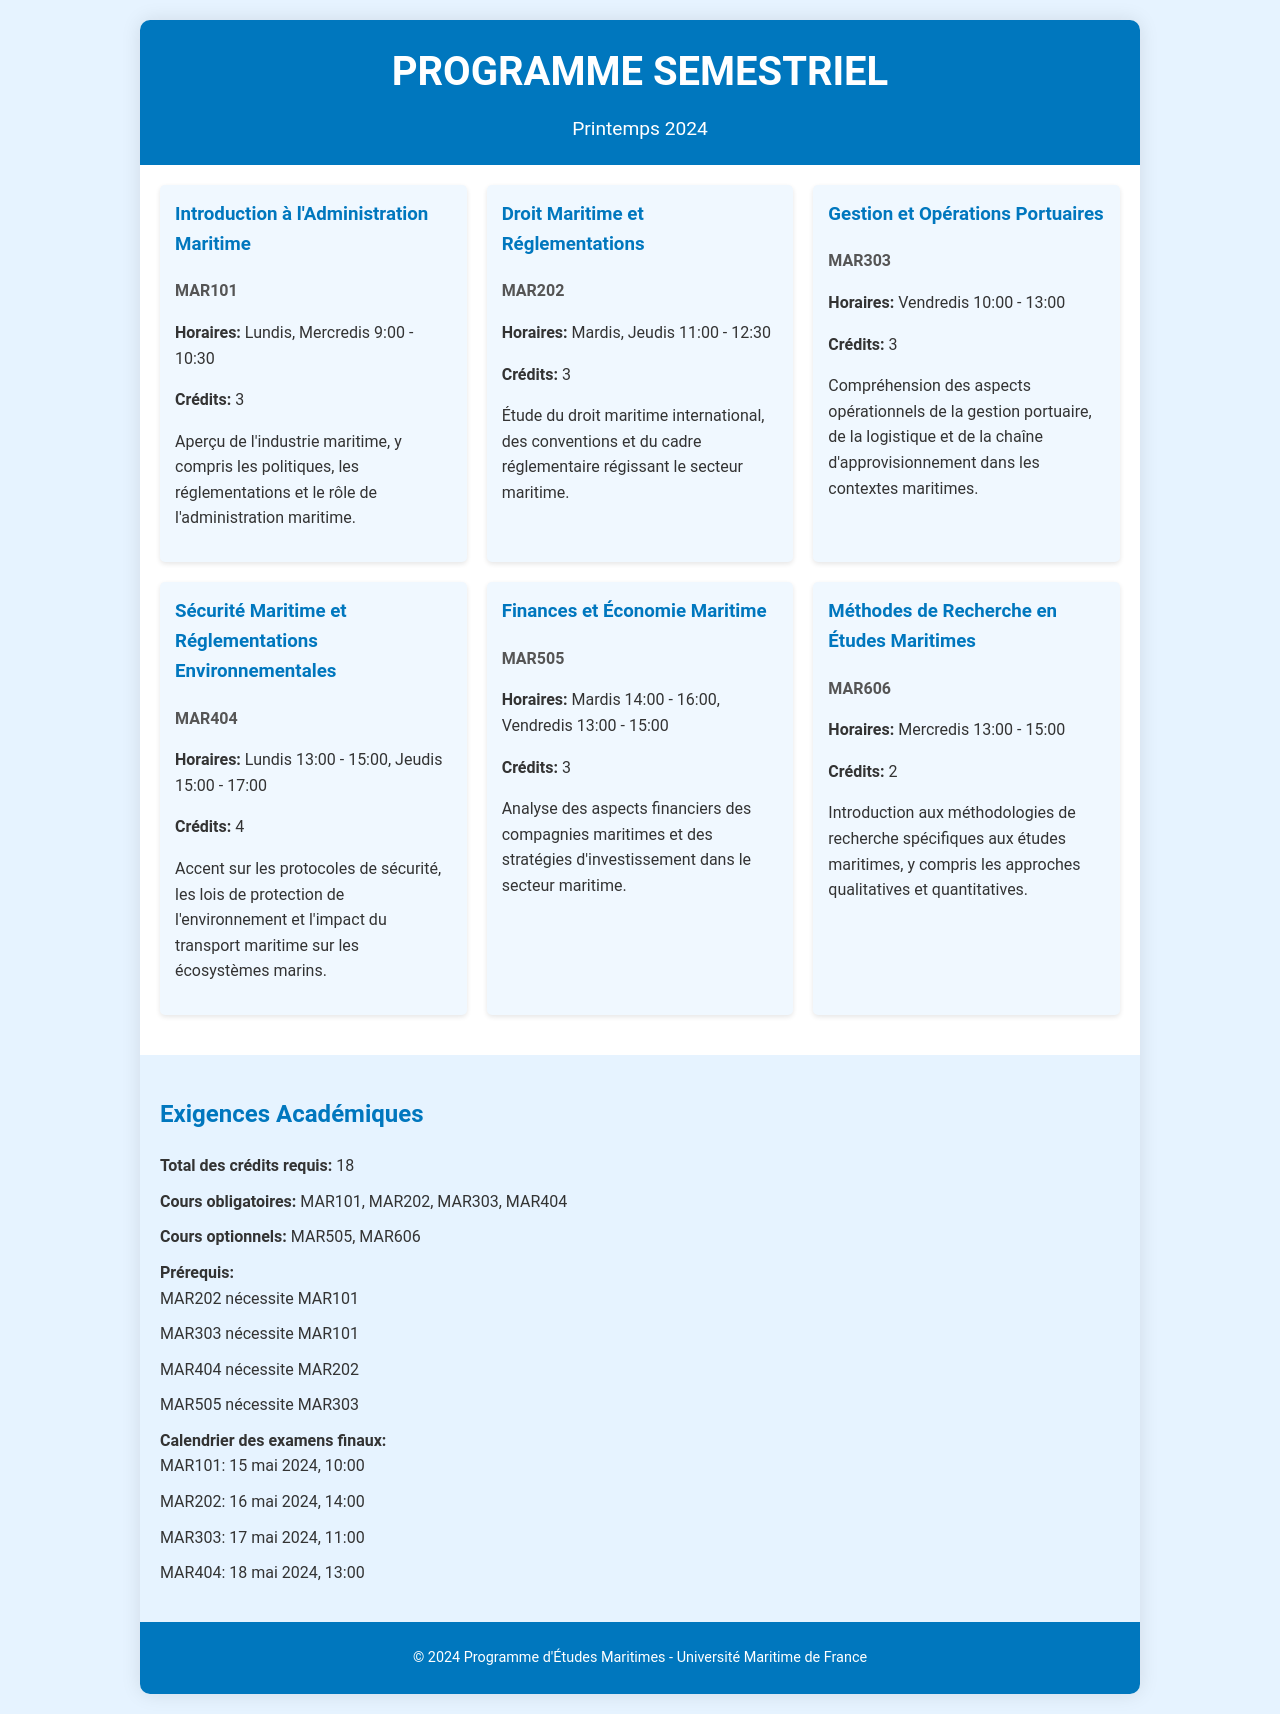Quel est le code du cours "Introduction à l'Administration Maritime"? Le code du cours est mentionné en dessous de son titre dans le document.
Answer: MAR101 Quels jours se déroule le cours "Droit Maritime et Réglementations"? Les jours de cours sont indiqués après le titre du cours, précisant les jours spécifiques.
Answer: Mardis, Jeudis Combien de crédits le cours "Sécurité Maritime et Réglementations Environnementales" rapporte-t-il? Le nombre de crédits est mentionné à côté de l'indication des cours.
Answer: 4 Quelles sont les heures du cours "Finances et Économie Maritime"? Les horaires de cours sont précisés sous le titre, indiquant les heures spécifiques.
Answer: Mardis 14:00 - 16:00, Vendredis 13:00 - 15:00 Quel est le total des crédits requis pour le semestre? Le total des crédits requis est indiqué dans la section des exigences académiques.
Answer: 18 Quel cours nécessite MAR202 comme prérequis? Les prérequis sont listés, indiquant les cours qui nécessitent d'autres cours comme condition.
Answer: MAR404 Quels sont les horaires du cours "Gestion et Opérations Portuaires"? Les horaires sont fournis sous le titre, mettant en évidence les jours et heures du cours.
Answer: Vendredis 10:00 - 13:00 Quand a lieu l’examen final du cours MAR303? La date de l’examen final est indiquée spécifiquement sous la section des examens.
Answer: 17 mai 2024, 11:00 Quel est le titre du cours à 3 crédits avec le code MAR505? Le titre du cours est mentionné juste avant le code et les heures.
Answer: Finances et Économie Maritime 